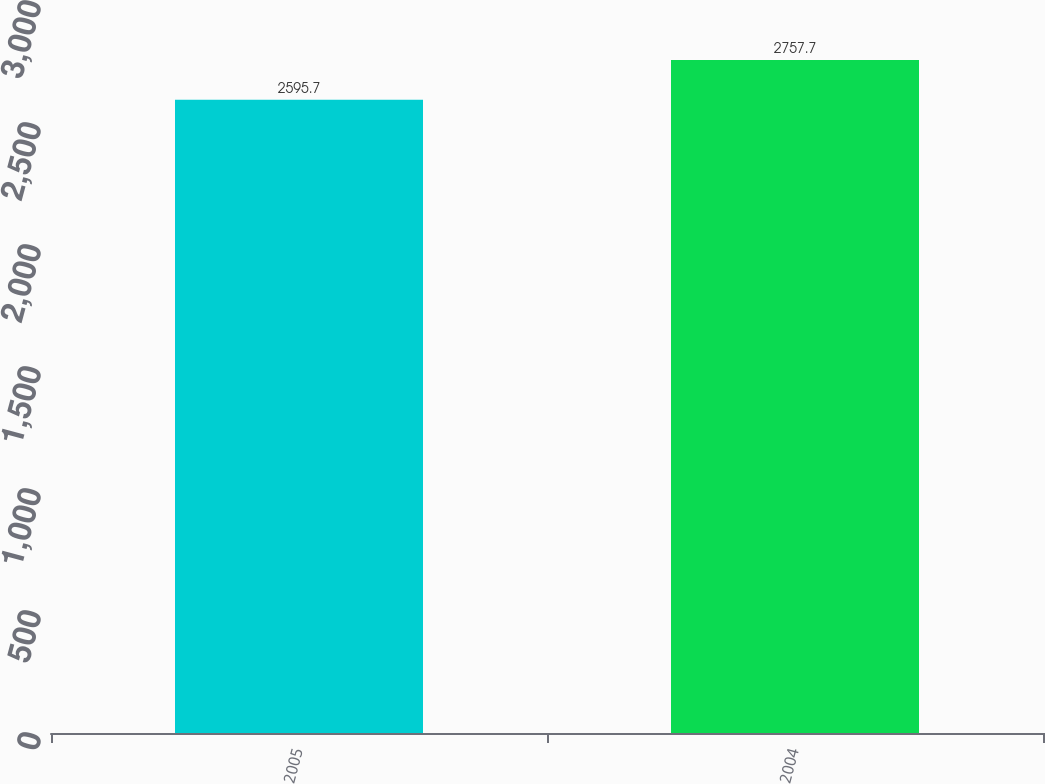Convert chart. <chart><loc_0><loc_0><loc_500><loc_500><bar_chart><fcel>2005<fcel>2004<nl><fcel>2595.7<fcel>2757.7<nl></chart> 